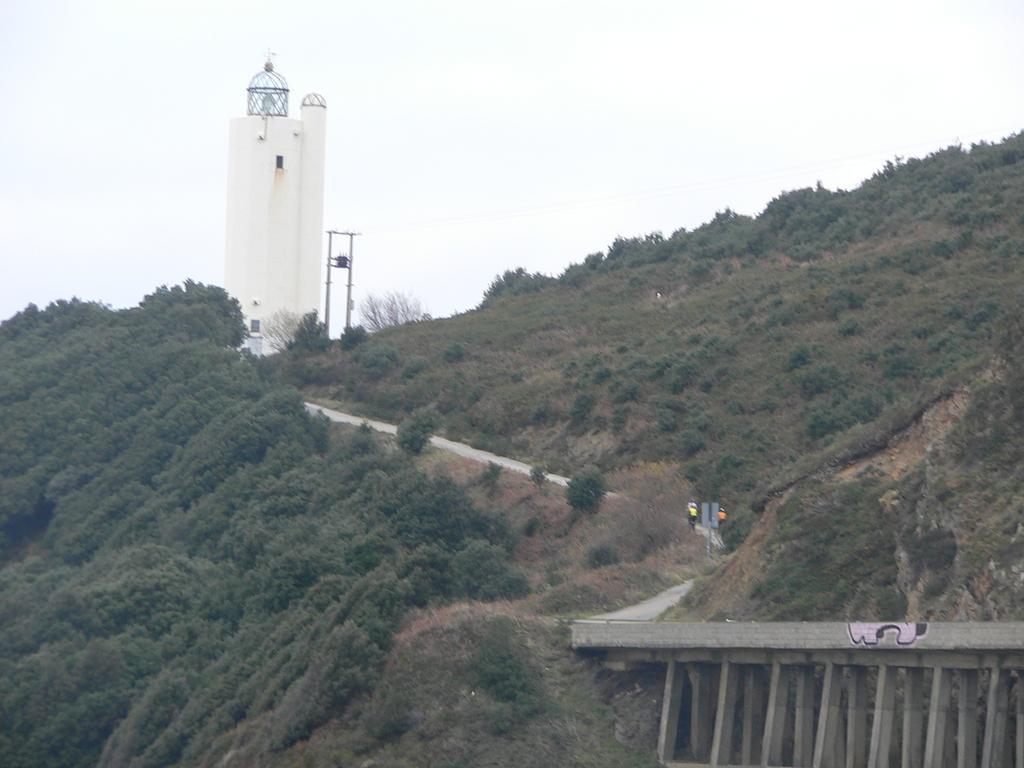Describe this image in one or two sentences. In the center of the image there is a tower. There are trees. There is a road. There is a bridge. 